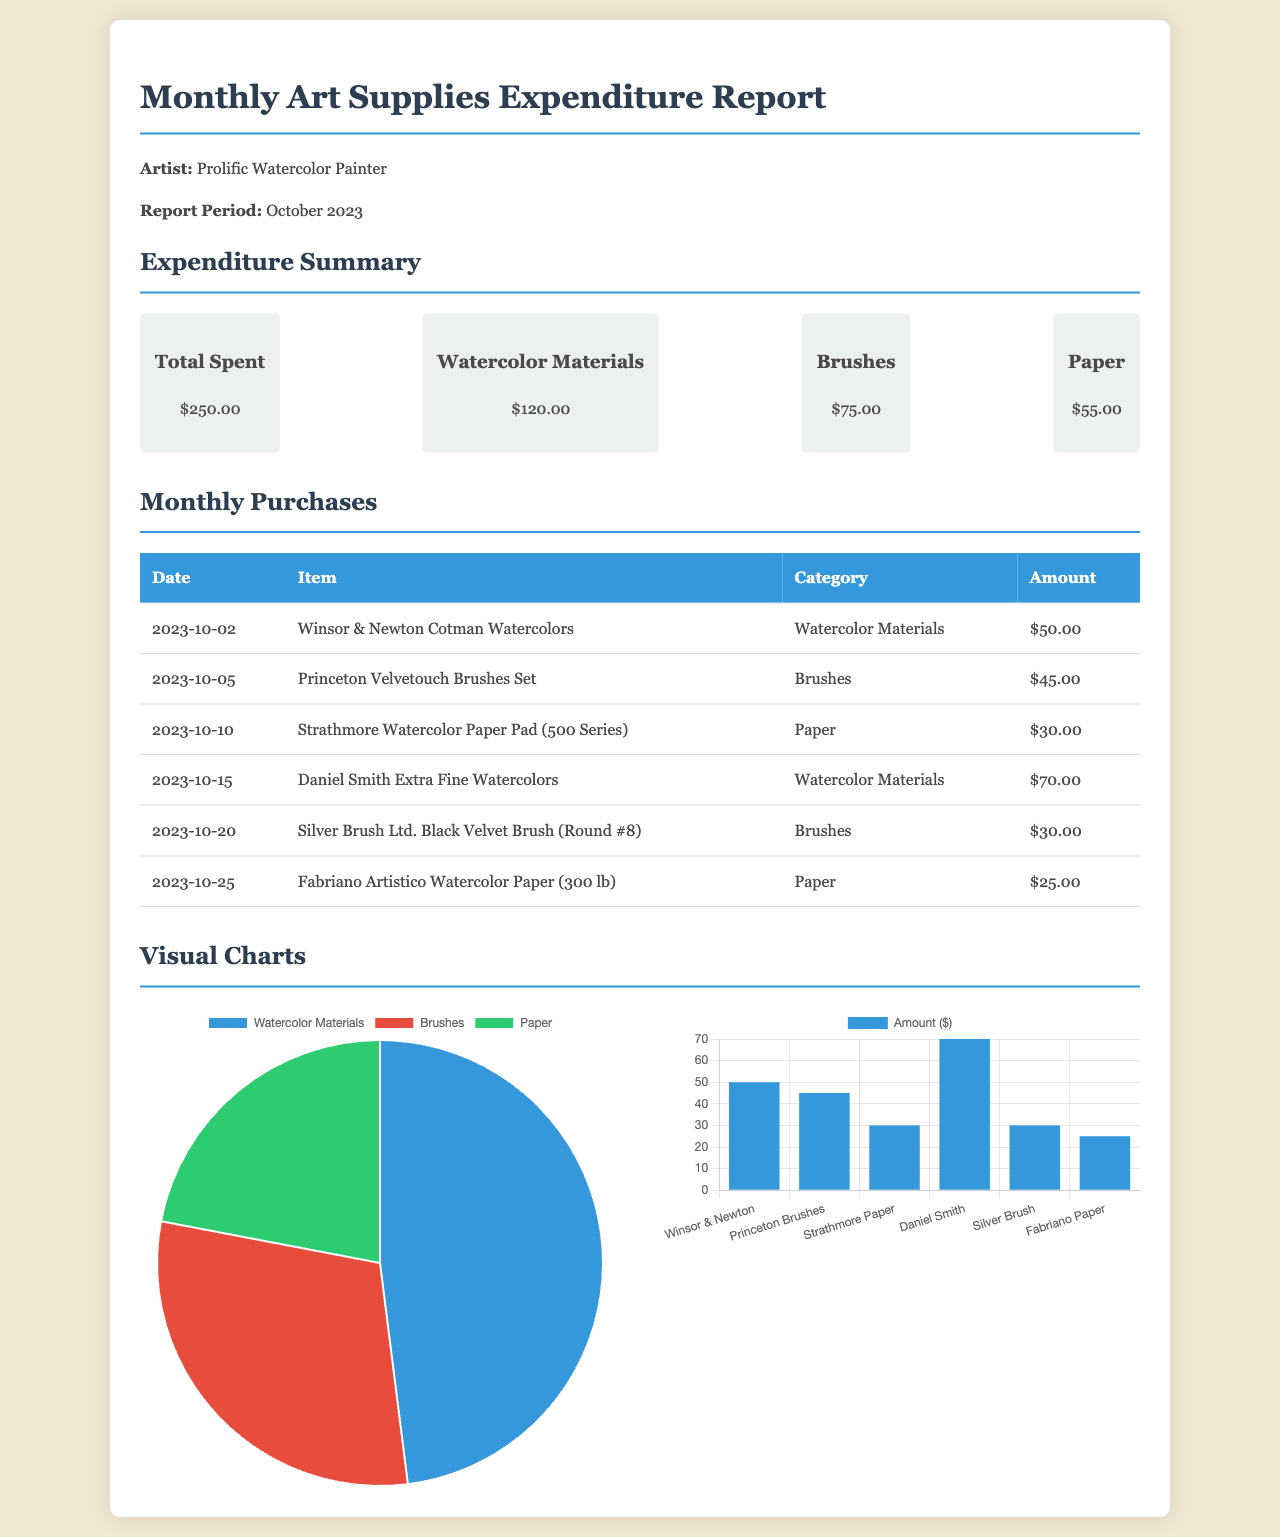what is the total amount spent on art supplies? The total amount spent is clearly stated in the summary section of the document.
Answer: $250.00 how much was spent on watercolor materials? This amount is specifically listed under the Expenditure Summary section for watercolor materials.
Answer: $120.00 what is the purchase date for Strathmore Watercolor Paper Pad? The purchase date is mentioned in the monthly purchases table for Strathmore Watercolor Paper Pad.
Answer: 2023-10-10 which item had the highest expenditure? The highest expenditure can be derived from the monthly purchases table, where the amounts are compared.
Answer: Daniel Smith Extra Fine Watercolors what percentage of the total expenditure was spent on brushes? This percentage is calculated based on the total spent and the amount on brushes, as shown in the Expenditure Summary.
Answer: 30% how many categories of supplies are tracked in the report? The number of categories can be found by counting the distinct categories mentioned in the Expenditure Summary.
Answer: 3 what chart type represents the expenditure distribution by category? The type of chart used for expenditure distribution is specifically indicated in the document.
Answer: pie which two items were purchased on the same date? This information requires looking at the monthly purchases table for items with matching dates.
Answer: No items what does the bar chart illustrate? The bar chart visualizes a specific aspect of the purchases, as described in the text.
Answer: Monthly Purchases 